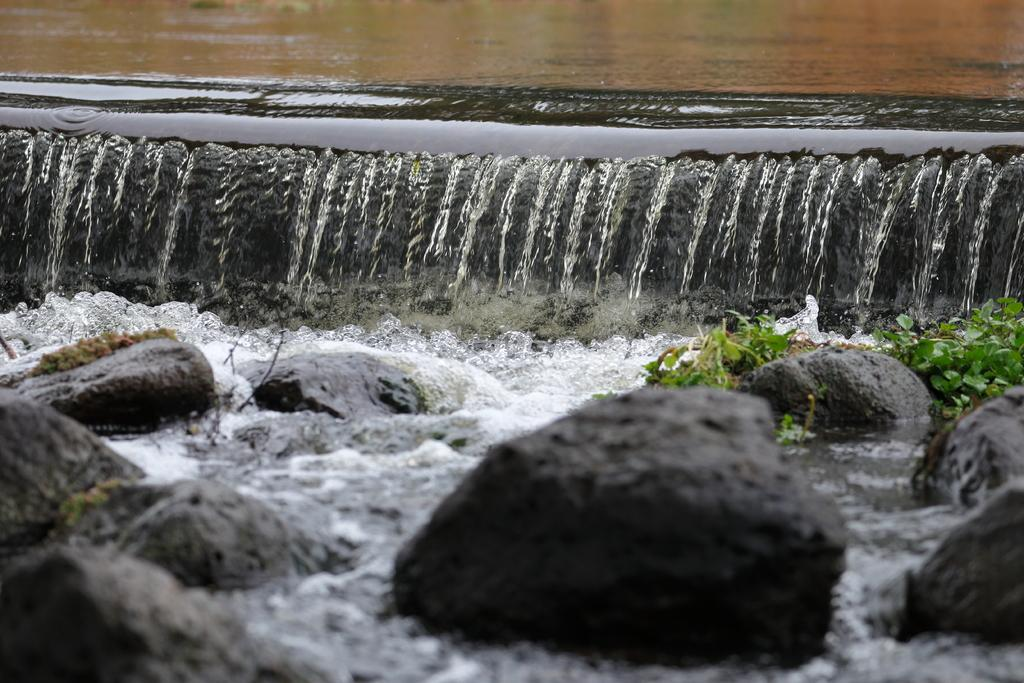What is happening in the image? There is water flowing in the image. What can be seen in the water? There are rocks visible in the image. What type of vegetation is present in the water? There are water plants in the image. What type of quiver can be seen in the image? There is no quiver present in the image. What route does the water follow in the image? The provided facts do not give information about the specific route the water follows in the image. 